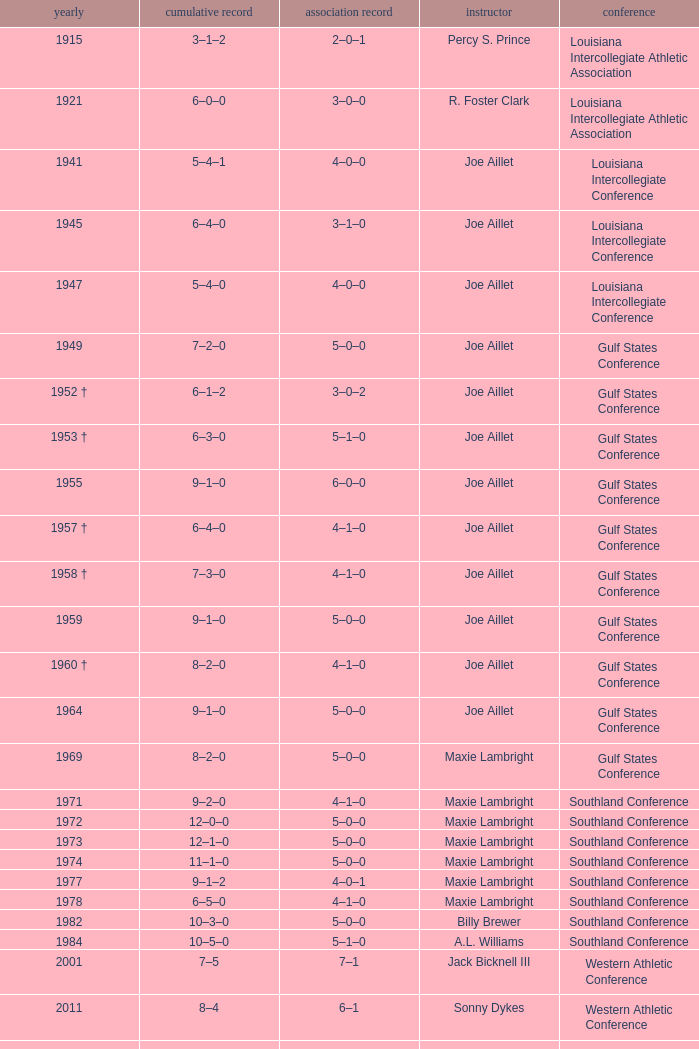Help me parse the entirety of this table. {'header': ['yearly', 'cumulative record', 'association record', 'instructor', 'conference'], 'rows': [['1915', '3–1–2', '2–0–1', 'Percy S. Prince', 'Louisiana Intercollegiate Athletic Association'], ['1921', '6–0–0', '3–0–0', 'R. Foster Clark', 'Louisiana Intercollegiate Athletic Association'], ['1941', '5–4–1', '4–0–0', 'Joe Aillet', 'Louisiana Intercollegiate Conference'], ['1945', '6–4–0', '3–1–0', 'Joe Aillet', 'Louisiana Intercollegiate Conference'], ['1947', '5–4–0', '4–0–0', 'Joe Aillet', 'Louisiana Intercollegiate Conference'], ['1949', '7–2–0', '5–0–0', 'Joe Aillet', 'Gulf States Conference'], ['1952 †', '6–1–2', '3–0–2', 'Joe Aillet', 'Gulf States Conference'], ['1953 †', '6–3–0', '5–1–0', 'Joe Aillet', 'Gulf States Conference'], ['1955', '9–1–0', '6–0–0', 'Joe Aillet', 'Gulf States Conference'], ['1957 †', '6–4–0', '4–1–0', 'Joe Aillet', 'Gulf States Conference'], ['1958 †', '7–3–0', '4–1–0', 'Joe Aillet', 'Gulf States Conference'], ['1959', '9–1–0', '5–0–0', 'Joe Aillet', 'Gulf States Conference'], ['1960 †', '8–2–0', '4–1–0', 'Joe Aillet', 'Gulf States Conference'], ['1964', '9–1–0', '5–0–0', 'Joe Aillet', 'Gulf States Conference'], ['1969', '8–2–0', '5–0–0', 'Maxie Lambright', 'Gulf States Conference'], ['1971', '9–2–0', '4–1–0', 'Maxie Lambright', 'Southland Conference'], ['1972', '12–0–0', '5–0–0', 'Maxie Lambright', 'Southland Conference'], ['1973', '12–1–0', '5–0–0', 'Maxie Lambright', 'Southland Conference'], ['1974', '11–1–0', '5–0–0', 'Maxie Lambright', 'Southland Conference'], ['1977', '9–1–2', '4–0–1', 'Maxie Lambright', 'Southland Conference'], ['1978', '6–5–0', '4–1–0', 'Maxie Lambright', 'Southland Conference'], ['1982', '10–3–0', '5–0–0', 'Billy Brewer', 'Southland Conference'], ['1984', '10–5–0', '5–1–0', 'A.L. Williams', 'Southland Conference'], ['2001', '7–5', '7–1', 'Jack Bicknell III', 'Western Athletic Conference'], ['2011', '8–4', '6–1', 'Sonny Dykes', 'Western Athletic Conference'], ['† Denotes co-champions', '† Denotes co-champions', '† Denotes co-champions', '† Denotes co-champions', '† Denotes co-champions']]} What is the conference record for the year of 1971? 4–1–0. 